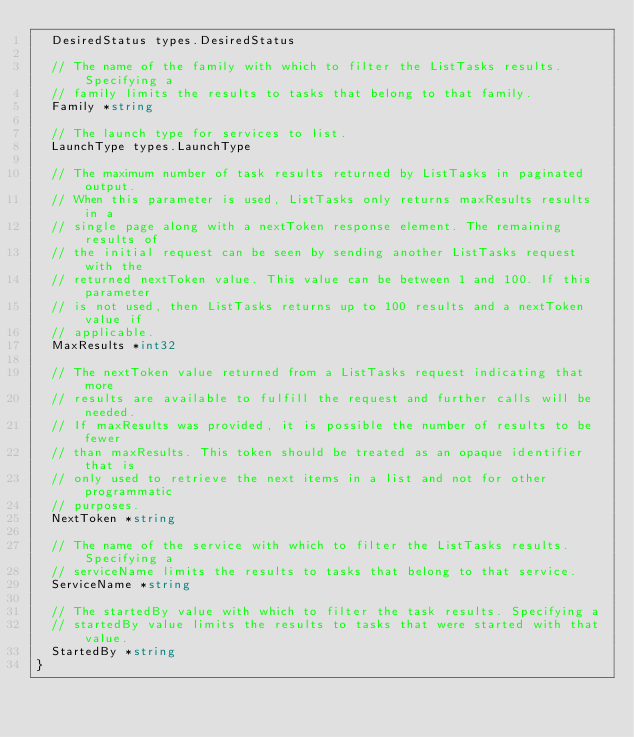<code> <loc_0><loc_0><loc_500><loc_500><_Go_>	DesiredStatus types.DesiredStatus

	// The name of the family with which to filter the ListTasks results. Specifying a
	// family limits the results to tasks that belong to that family.
	Family *string

	// The launch type for services to list.
	LaunchType types.LaunchType

	// The maximum number of task results returned by ListTasks in paginated output.
	// When this parameter is used, ListTasks only returns maxResults results in a
	// single page along with a nextToken response element. The remaining results of
	// the initial request can be seen by sending another ListTasks request with the
	// returned nextToken value. This value can be between 1 and 100. If this parameter
	// is not used, then ListTasks returns up to 100 results and a nextToken value if
	// applicable.
	MaxResults *int32

	// The nextToken value returned from a ListTasks request indicating that more
	// results are available to fulfill the request and further calls will be needed.
	// If maxResults was provided, it is possible the number of results to be fewer
	// than maxResults. This token should be treated as an opaque identifier that is
	// only used to retrieve the next items in a list and not for other programmatic
	// purposes.
	NextToken *string

	// The name of the service with which to filter the ListTasks results. Specifying a
	// serviceName limits the results to tasks that belong to that service.
	ServiceName *string

	// The startedBy value with which to filter the task results. Specifying a
	// startedBy value limits the results to tasks that were started with that value.
	StartedBy *string
}
</code> 